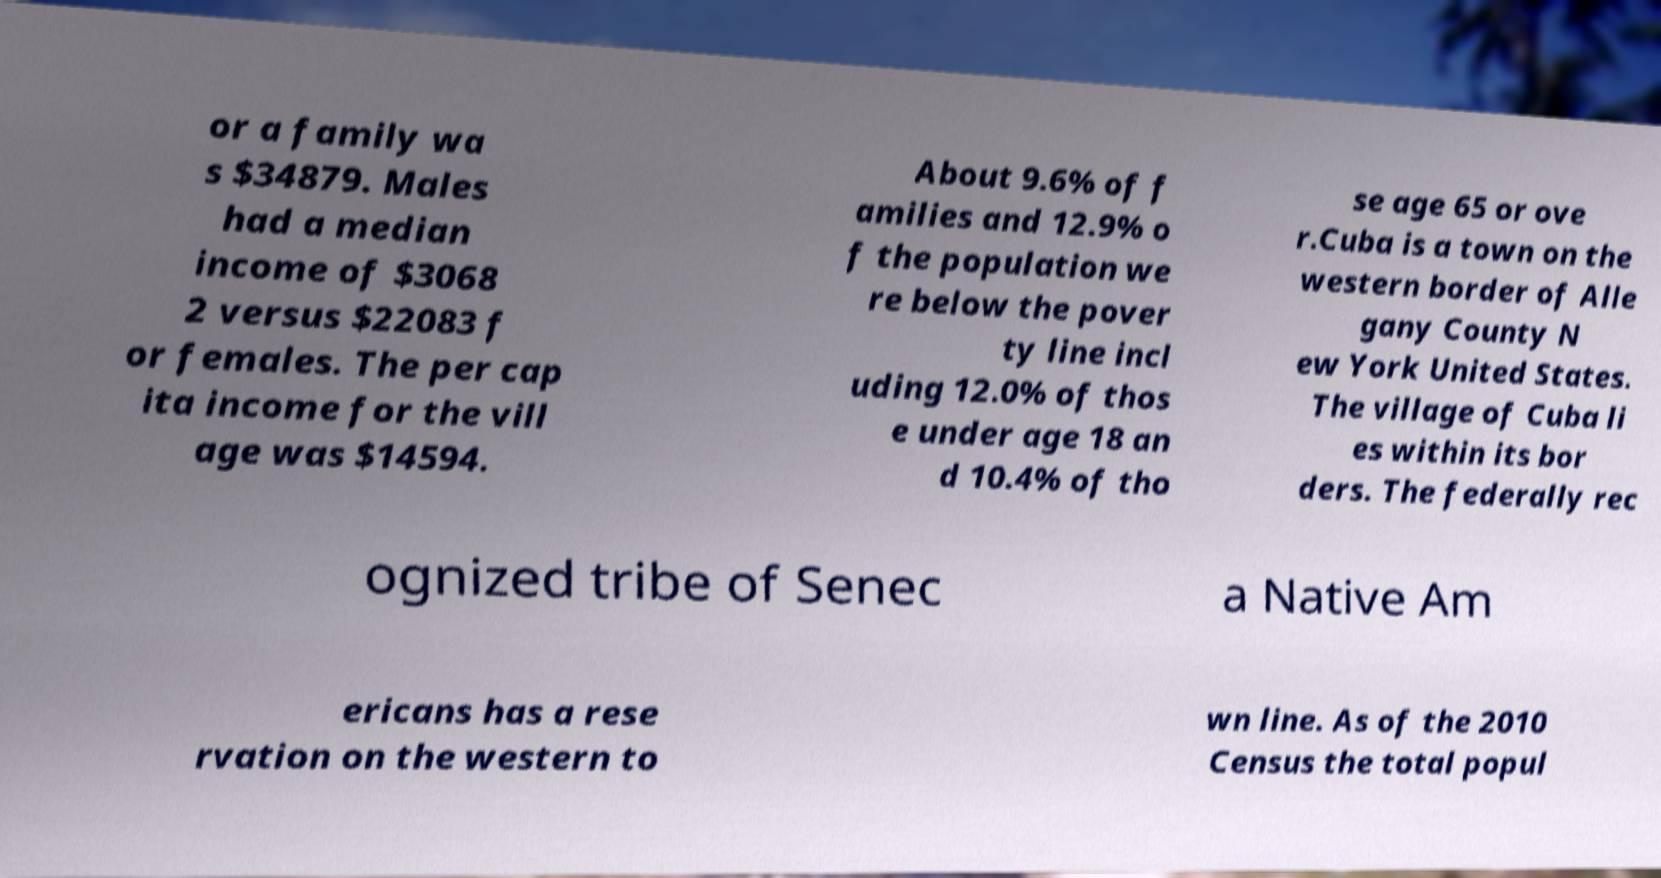There's text embedded in this image that I need extracted. Can you transcribe it verbatim? or a family wa s $34879. Males had a median income of $3068 2 versus $22083 f or females. The per cap ita income for the vill age was $14594. About 9.6% of f amilies and 12.9% o f the population we re below the pover ty line incl uding 12.0% of thos e under age 18 an d 10.4% of tho se age 65 or ove r.Cuba is a town on the western border of Alle gany County N ew York United States. The village of Cuba li es within its bor ders. The federally rec ognized tribe of Senec a Native Am ericans has a rese rvation on the western to wn line. As of the 2010 Census the total popul 